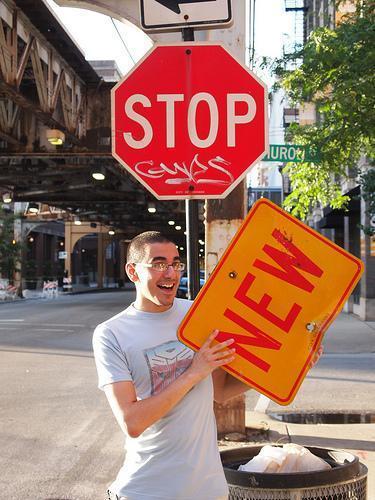How many trash cans are in the photograph?
Give a very brief answer. 1. How many signs are in the picture?
Give a very brief answer. 4. How many people are in the picture?
Give a very brief answer. 1. 